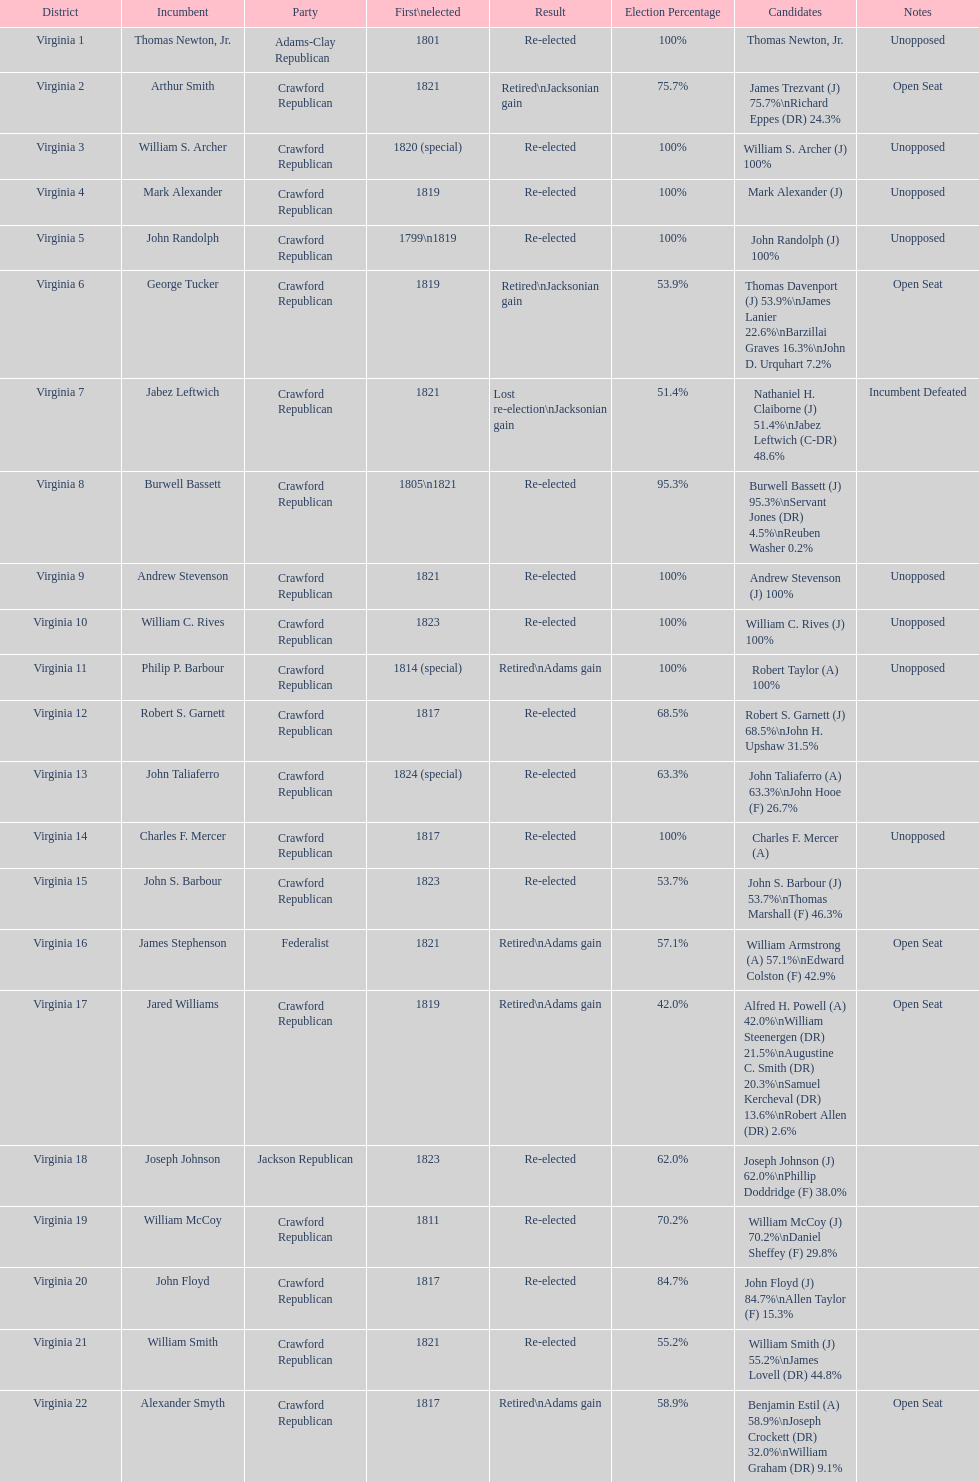Number of incumbents who retired or lost re-election 7. 